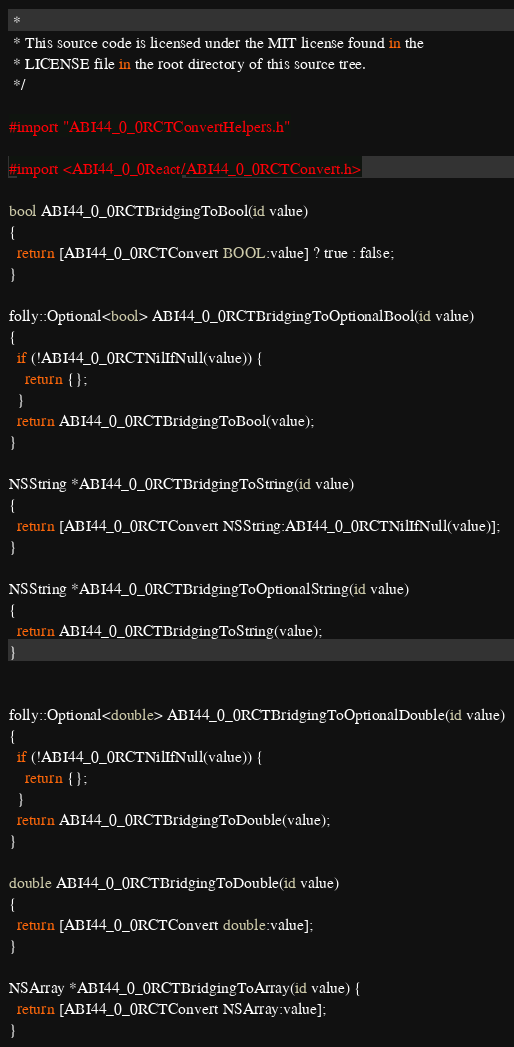<code> <loc_0><loc_0><loc_500><loc_500><_ObjectiveC_> *
 * This source code is licensed under the MIT license found in the
 * LICENSE file in the root directory of this source tree.
 */

#import "ABI44_0_0RCTConvertHelpers.h"

#import <ABI44_0_0React/ABI44_0_0RCTConvert.h>

bool ABI44_0_0RCTBridgingToBool(id value)
{
  return [ABI44_0_0RCTConvert BOOL:value] ? true : false;
}

folly::Optional<bool> ABI44_0_0RCTBridgingToOptionalBool(id value)
{
  if (!ABI44_0_0RCTNilIfNull(value)) {
    return {};
  }
  return ABI44_0_0RCTBridgingToBool(value);
}

NSString *ABI44_0_0RCTBridgingToString(id value)
{
  return [ABI44_0_0RCTConvert NSString:ABI44_0_0RCTNilIfNull(value)];
}

NSString *ABI44_0_0RCTBridgingToOptionalString(id value)
{
  return ABI44_0_0RCTBridgingToString(value);
}


folly::Optional<double> ABI44_0_0RCTBridgingToOptionalDouble(id value)
{
  if (!ABI44_0_0RCTNilIfNull(value)) {
    return {};
  }
  return ABI44_0_0RCTBridgingToDouble(value);
}

double ABI44_0_0RCTBridgingToDouble(id value)
{
  return [ABI44_0_0RCTConvert double:value];
}

NSArray *ABI44_0_0RCTBridgingToArray(id value) {
  return [ABI44_0_0RCTConvert NSArray:value];
}
</code> 